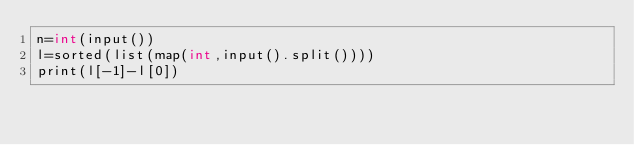Convert code to text. <code><loc_0><loc_0><loc_500><loc_500><_Cython_>n=int(input())
l=sorted(list(map(int,input().split())))
print(l[-1]-l[0])</code> 